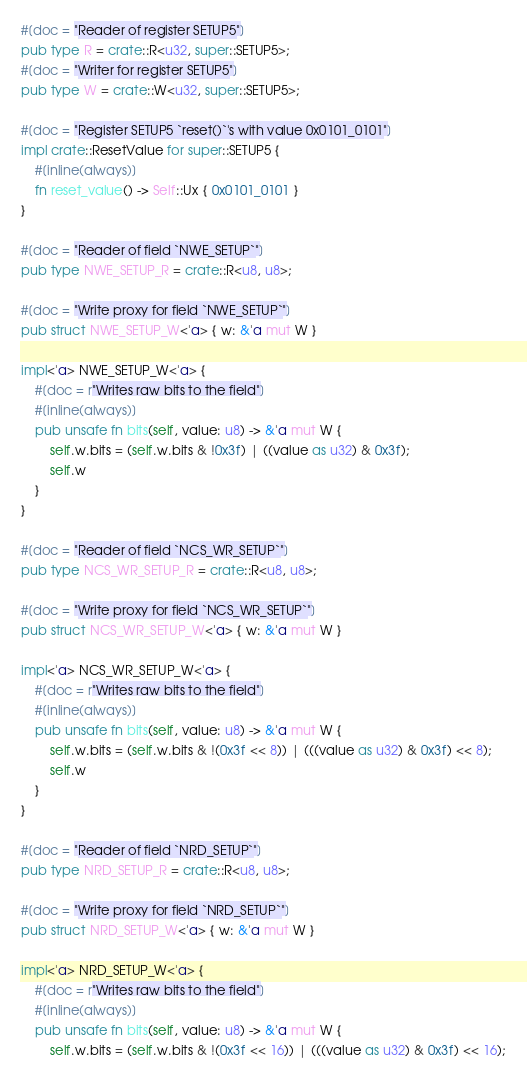Convert code to text. <code><loc_0><loc_0><loc_500><loc_500><_Rust_>#[doc = "Reader of register SETUP5"]
pub type R = crate::R<u32, super::SETUP5>;
#[doc = "Writer for register SETUP5"]
pub type W = crate::W<u32, super::SETUP5>;

#[doc = "Register SETUP5 `reset()`'s with value 0x0101_0101"]
impl crate::ResetValue for super::SETUP5 {
    #[inline(always)]
    fn reset_value() -> Self::Ux { 0x0101_0101 }
}

#[doc = "Reader of field `NWE_SETUP`"]
pub type NWE_SETUP_R = crate::R<u8, u8>;

#[doc = "Write proxy for field `NWE_SETUP`"]
pub struct NWE_SETUP_W<'a> { w: &'a mut W }

impl<'a> NWE_SETUP_W<'a> {
    #[doc = r"Writes raw bits to the field"]
    #[inline(always)]
    pub unsafe fn bits(self, value: u8) -> &'a mut W {
        self.w.bits = (self.w.bits & !0x3f) | ((value as u32) & 0x3f);
        self.w
    }
}

#[doc = "Reader of field `NCS_WR_SETUP`"]
pub type NCS_WR_SETUP_R = crate::R<u8, u8>;

#[doc = "Write proxy for field `NCS_WR_SETUP`"]
pub struct NCS_WR_SETUP_W<'a> { w: &'a mut W }

impl<'a> NCS_WR_SETUP_W<'a> {
    #[doc = r"Writes raw bits to the field"]
    #[inline(always)]
    pub unsafe fn bits(self, value: u8) -> &'a mut W {
        self.w.bits = (self.w.bits & !(0x3f << 8)) | (((value as u32) & 0x3f) << 8);
        self.w
    }
}

#[doc = "Reader of field `NRD_SETUP`"]
pub type NRD_SETUP_R = crate::R<u8, u8>;

#[doc = "Write proxy for field `NRD_SETUP`"]
pub struct NRD_SETUP_W<'a> { w: &'a mut W }

impl<'a> NRD_SETUP_W<'a> {
    #[doc = r"Writes raw bits to the field"]
    #[inline(always)]
    pub unsafe fn bits(self, value: u8) -> &'a mut W {
        self.w.bits = (self.w.bits & !(0x3f << 16)) | (((value as u32) & 0x3f) << 16);</code> 